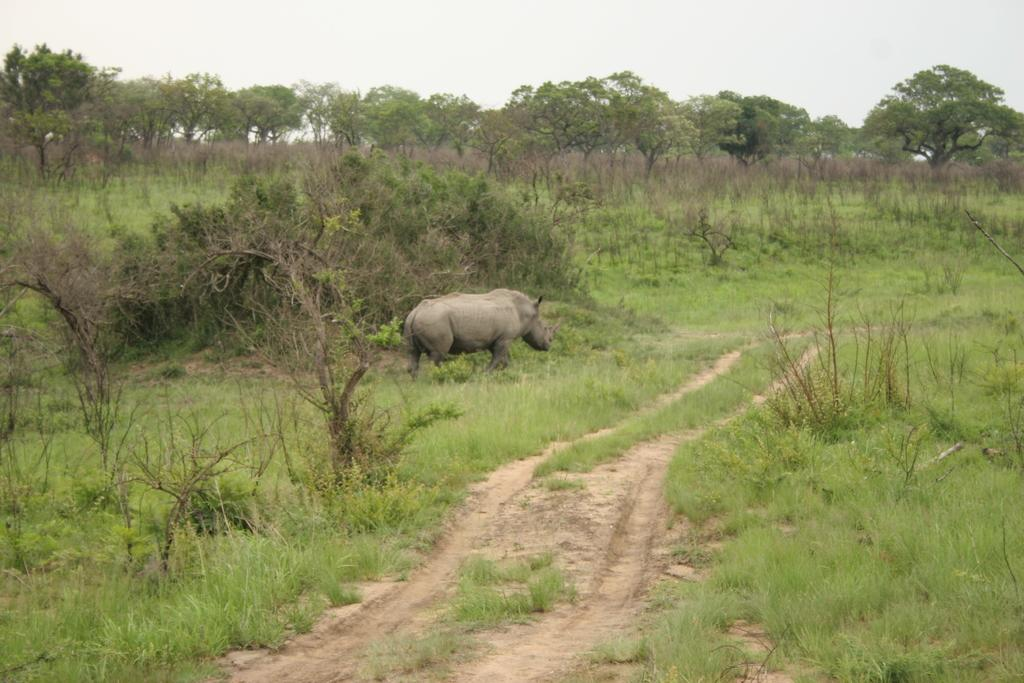What animal is the main subject of the picture? There is a rhino in the picture. What type of vegetation can be seen in the background of the picture? There is grass and trees in the background of the picture. Where is the nest located in the picture? There is no nest present in the picture; it features a rhino and vegetation in the background. What type of friction can be observed between the rhino and the grass? There is no friction mentioned or observable in the image; it simply shows a rhino and the surrounding vegetation. 